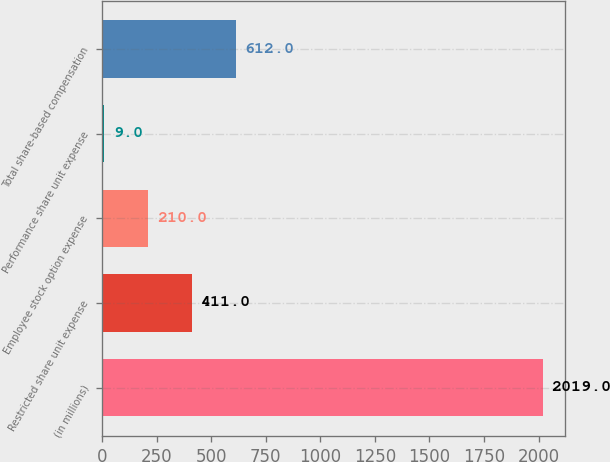Convert chart to OTSL. <chart><loc_0><loc_0><loc_500><loc_500><bar_chart><fcel>(in millions)<fcel>Restricted share unit expense<fcel>Employee stock option expense<fcel>Performance share unit expense<fcel>Total share-based compensation<nl><fcel>2019<fcel>411<fcel>210<fcel>9<fcel>612<nl></chart> 